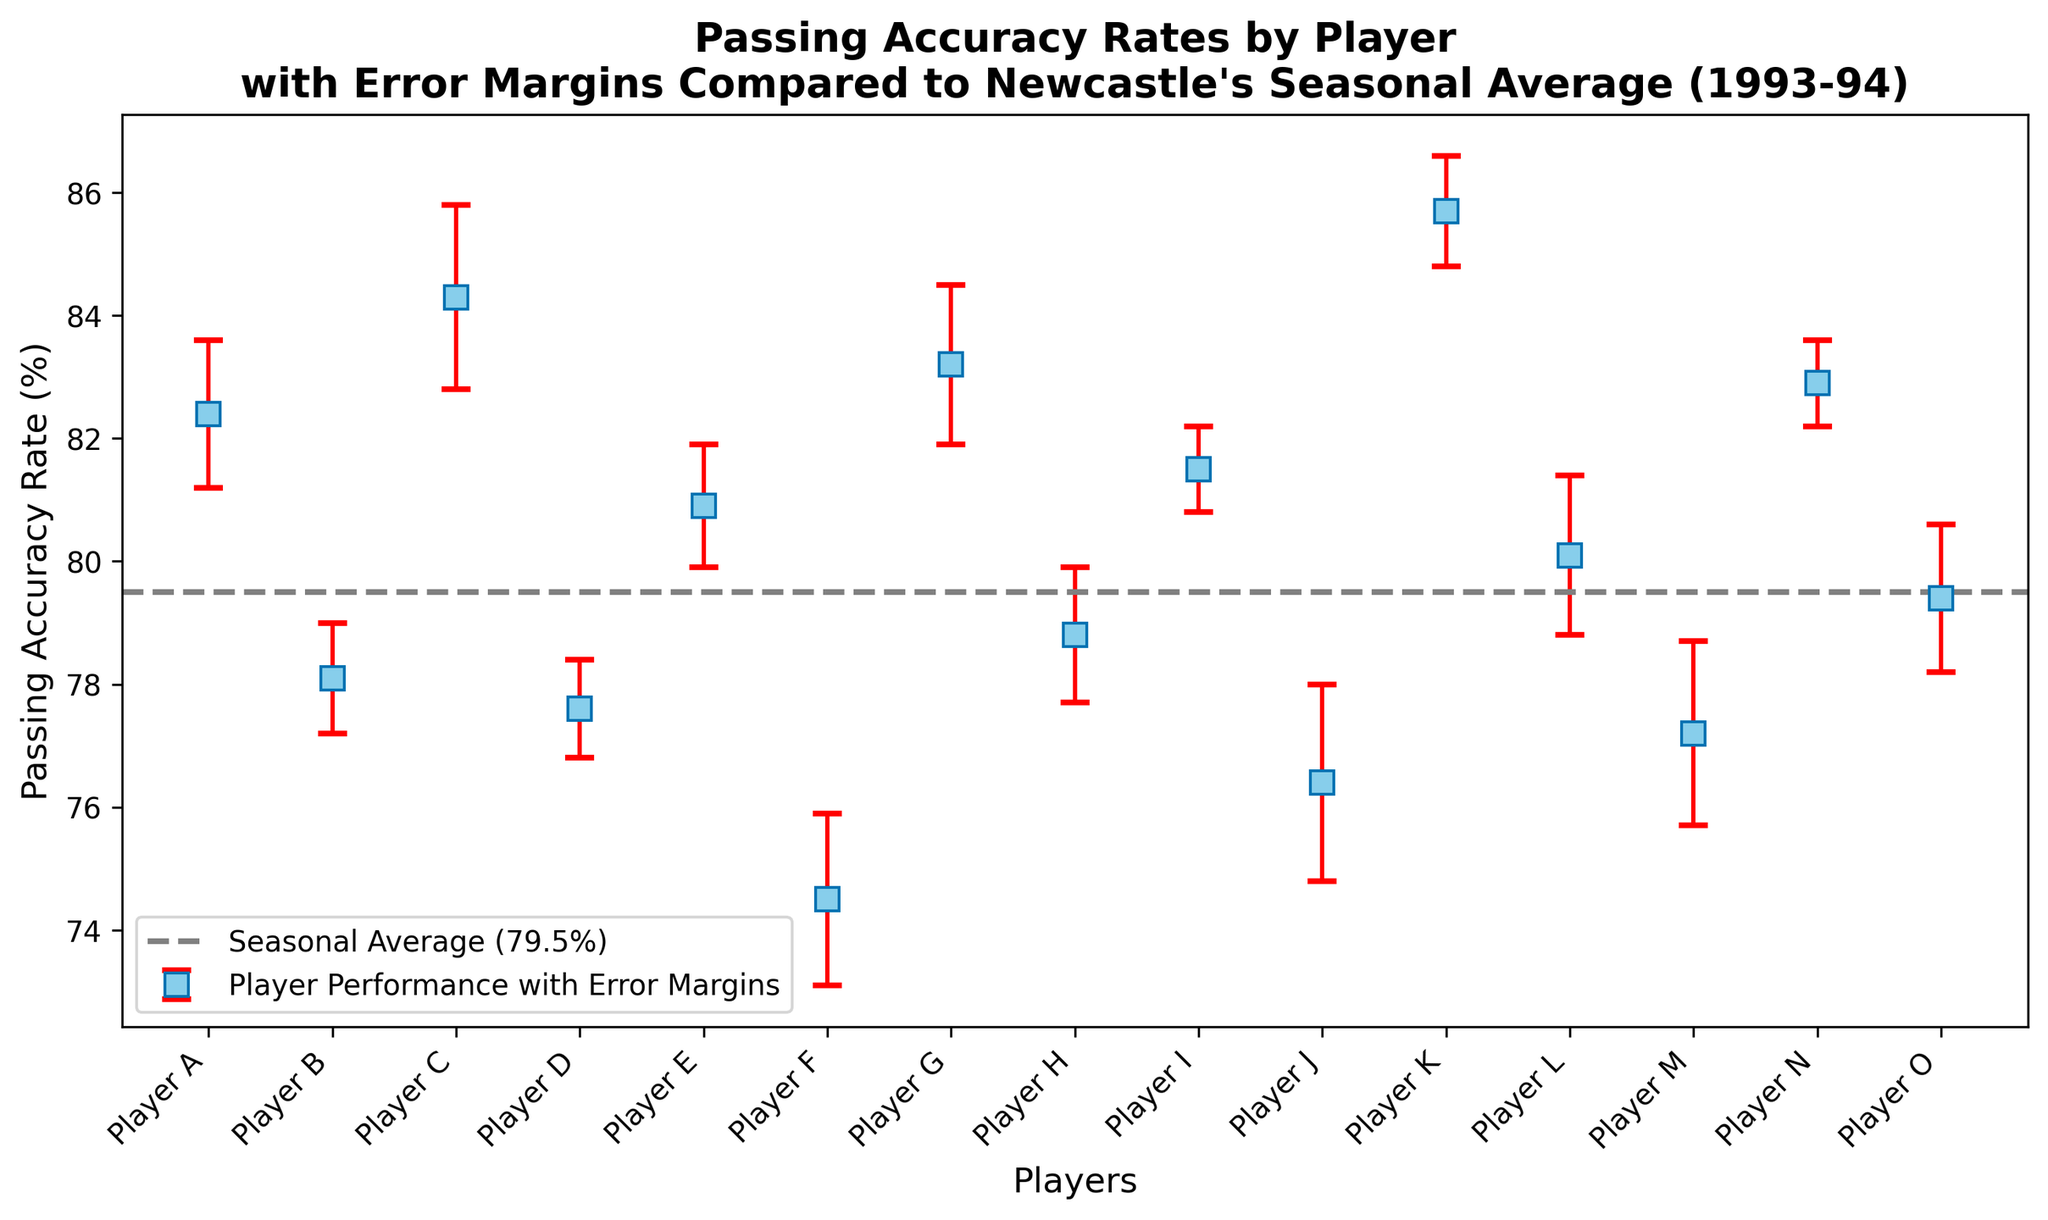What is the passing accuracy rate of Player K compared to the seasonal average? Player K's passing accuracy rate is shown as 85.7%, while the seasonal average is displayed as 79.5% on the horizontal line. To compare, subtract the seasonal average from Player K's rate: 85.7% - 79.5% = 6.2%.
Answer: 6.2% Which player has the lowest passing accuracy rate? Looking at the plot, Player F has the lowest passing accuracy rate, indicated by the position of the markers. Player F's rate is 74.5%.
Answer: Player F What is the error margin for Player A's passing accuracy rate? The figure shows error bars for each player's passing accuracy rate. For Player A, the error margin is represented by the length of the red error bar, and it is marked as 1.2%.
Answer: 1.2% How many players have a passing accuracy rate above the seasonal average? To determine this, count the players whose markers are above the gray horizontal line indicating the seasonal average (79.5%). Players A, C, E, G, I, K, L, and N have passing rates above the seasonal average. Counting these players gives 8.
Answer: 8 Which player has the largest error margin, and what is its value? The plot's red error bars indicate error margins. Player J has the longest error bar, indicating the largest error margin, which is 1.6%.
Answer: Player J, 1.6% What is the average passing accuracy rate of players with rates above the seasonal average? Identify players above the seasonal average (A, C, E, G, I, K, L, N). Their rates are 82.4%, 84.3%, 80.9%, 83.2%, 81.5%, 85.7%, 80.1%, and 82.9%. Calculating average: (82.4 + 84.3 + 80.9 + 83.2 + 81.5 + 85.7 + 80.1 + 82.9) / 8 = 83.88%.
Answer: 83.88% Which player has the passing accuracy rate closest to the seasonal average? To find this, check the distances of all players' rates from the seasonal average of 79.5%. Player O has the closest rate at 79.4%.
Answer: Player O Are there more players with passing accuracy rates above or below the seasonal average? Count the players above (A, C, E, G, I, K, L, N) and below (B, D, F, H, J, M, O) the seasonal average of 79.5%. There are 8 above and 7 below.
Answer: More above What is the difference in passing accuracy rate between Players A and B? Player A's rate is 82.4% and Player B's rate is 78.1%. Calculate the difference: 82.4% - 78.1% = 4.3%.
Answer: 4.3% What is the error margin range among all players? The smallest error margin is 0.7% (Players I and N) and the largest is 1.6% (Player J), giving a range of 1.6% - 0.7% = 0.9%.
Answer: 0.9% 